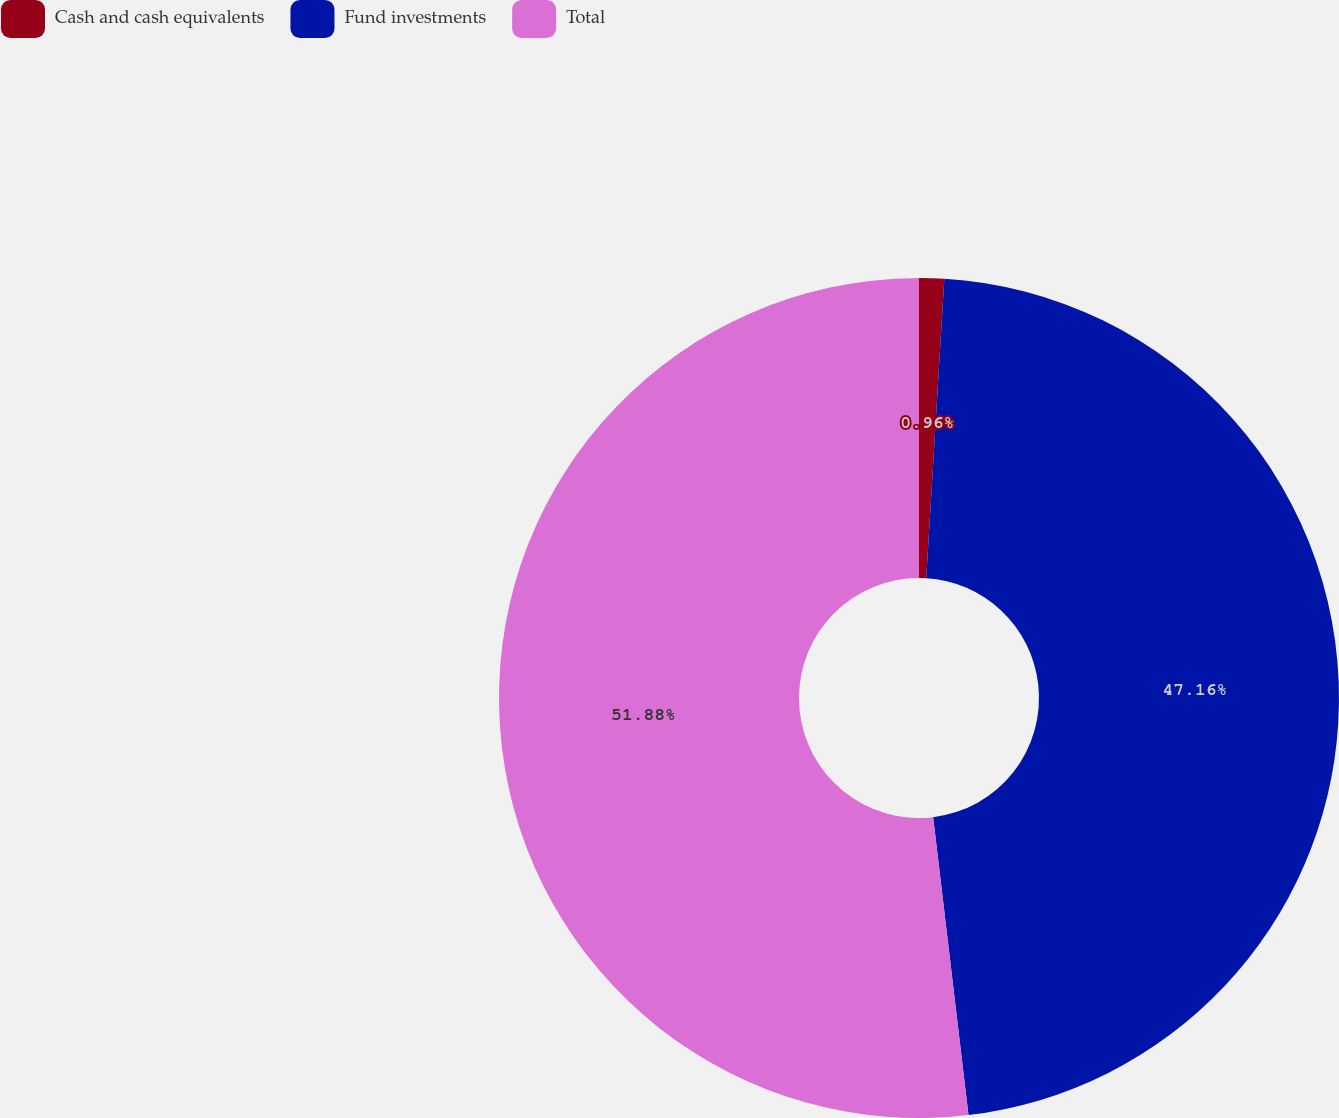<chart> <loc_0><loc_0><loc_500><loc_500><pie_chart><fcel>Cash and cash equivalents<fcel>Fund investments<fcel>Total<nl><fcel>0.96%<fcel>47.16%<fcel>51.88%<nl></chart> 